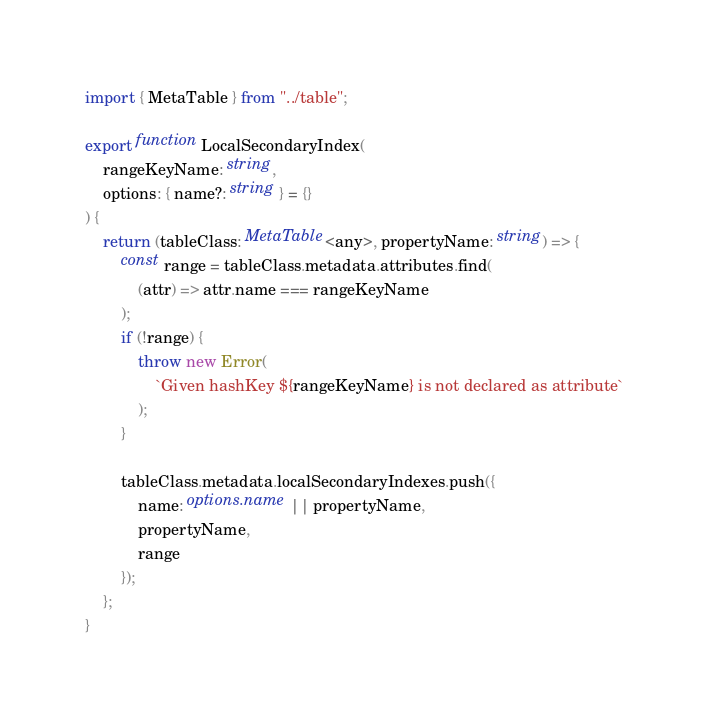Convert code to text. <code><loc_0><loc_0><loc_500><loc_500><_TypeScript_>import { MetaTable } from "../table";

export function LocalSecondaryIndex(
    rangeKeyName: string,
    options: { name?: string } = {}
) {
    return (tableClass: MetaTable<any>, propertyName: string) => {
        const range = tableClass.metadata.attributes.find(
            (attr) => attr.name === rangeKeyName
        );
        if (!range) {
            throw new Error(
                `Given hashKey ${rangeKeyName} is not declared as attribute`
            );
        }

        tableClass.metadata.localSecondaryIndexes.push({
            name: options.name || propertyName,
            propertyName,
            range
        });
    };
}
</code> 